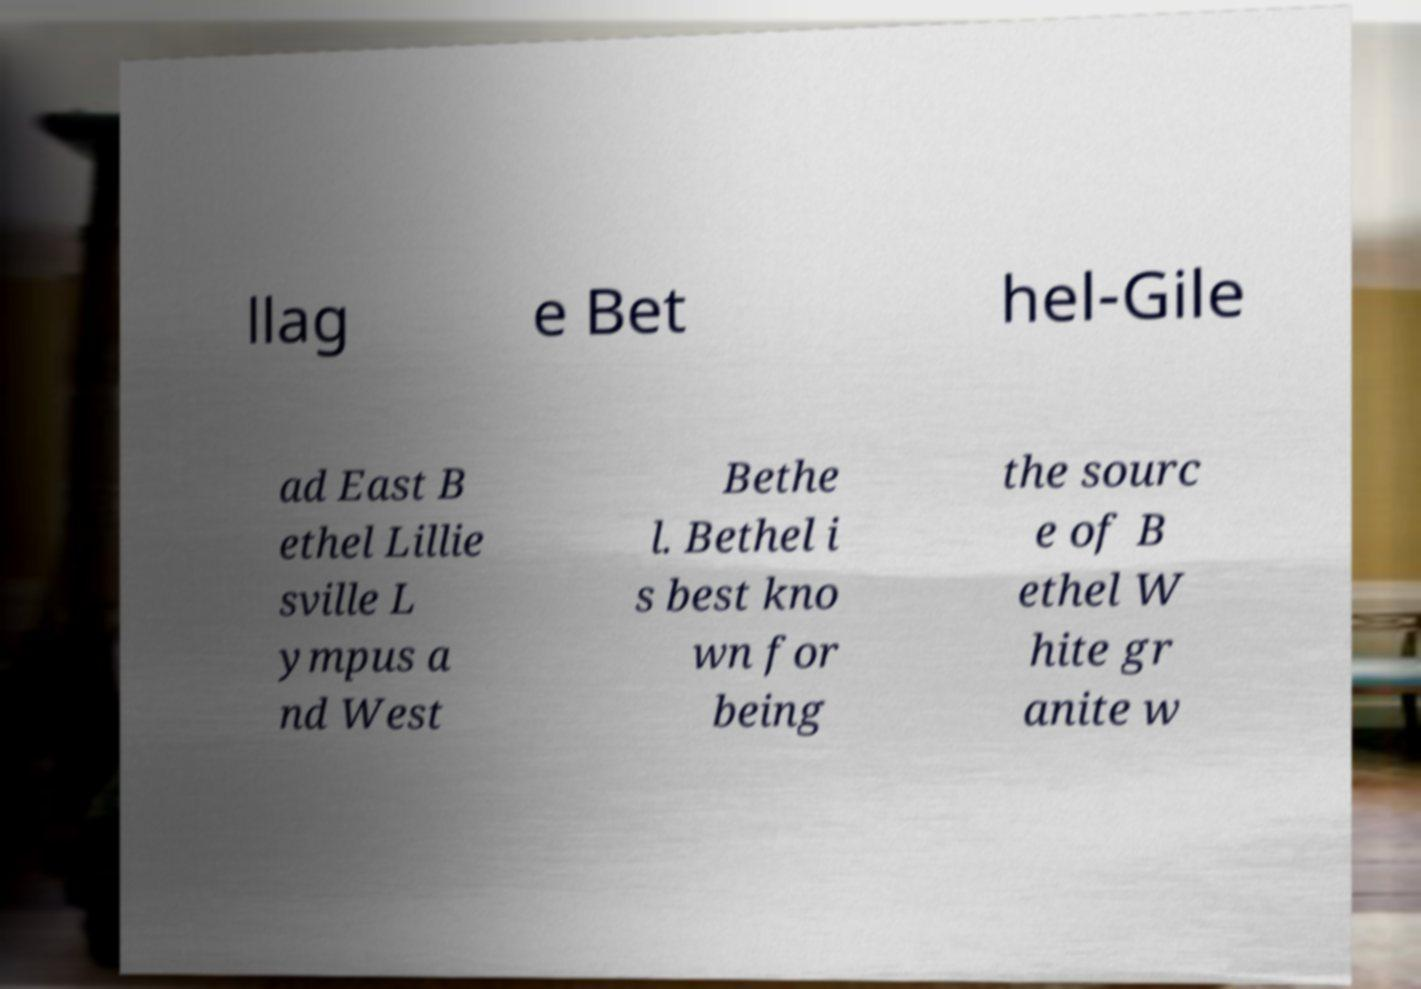For documentation purposes, I need the text within this image transcribed. Could you provide that? llag e Bet hel-Gile ad East B ethel Lillie sville L ympus a nd West Bethe l. Bethel i s best kno wn for being the sourc e of B ethel W hite gr anite w 